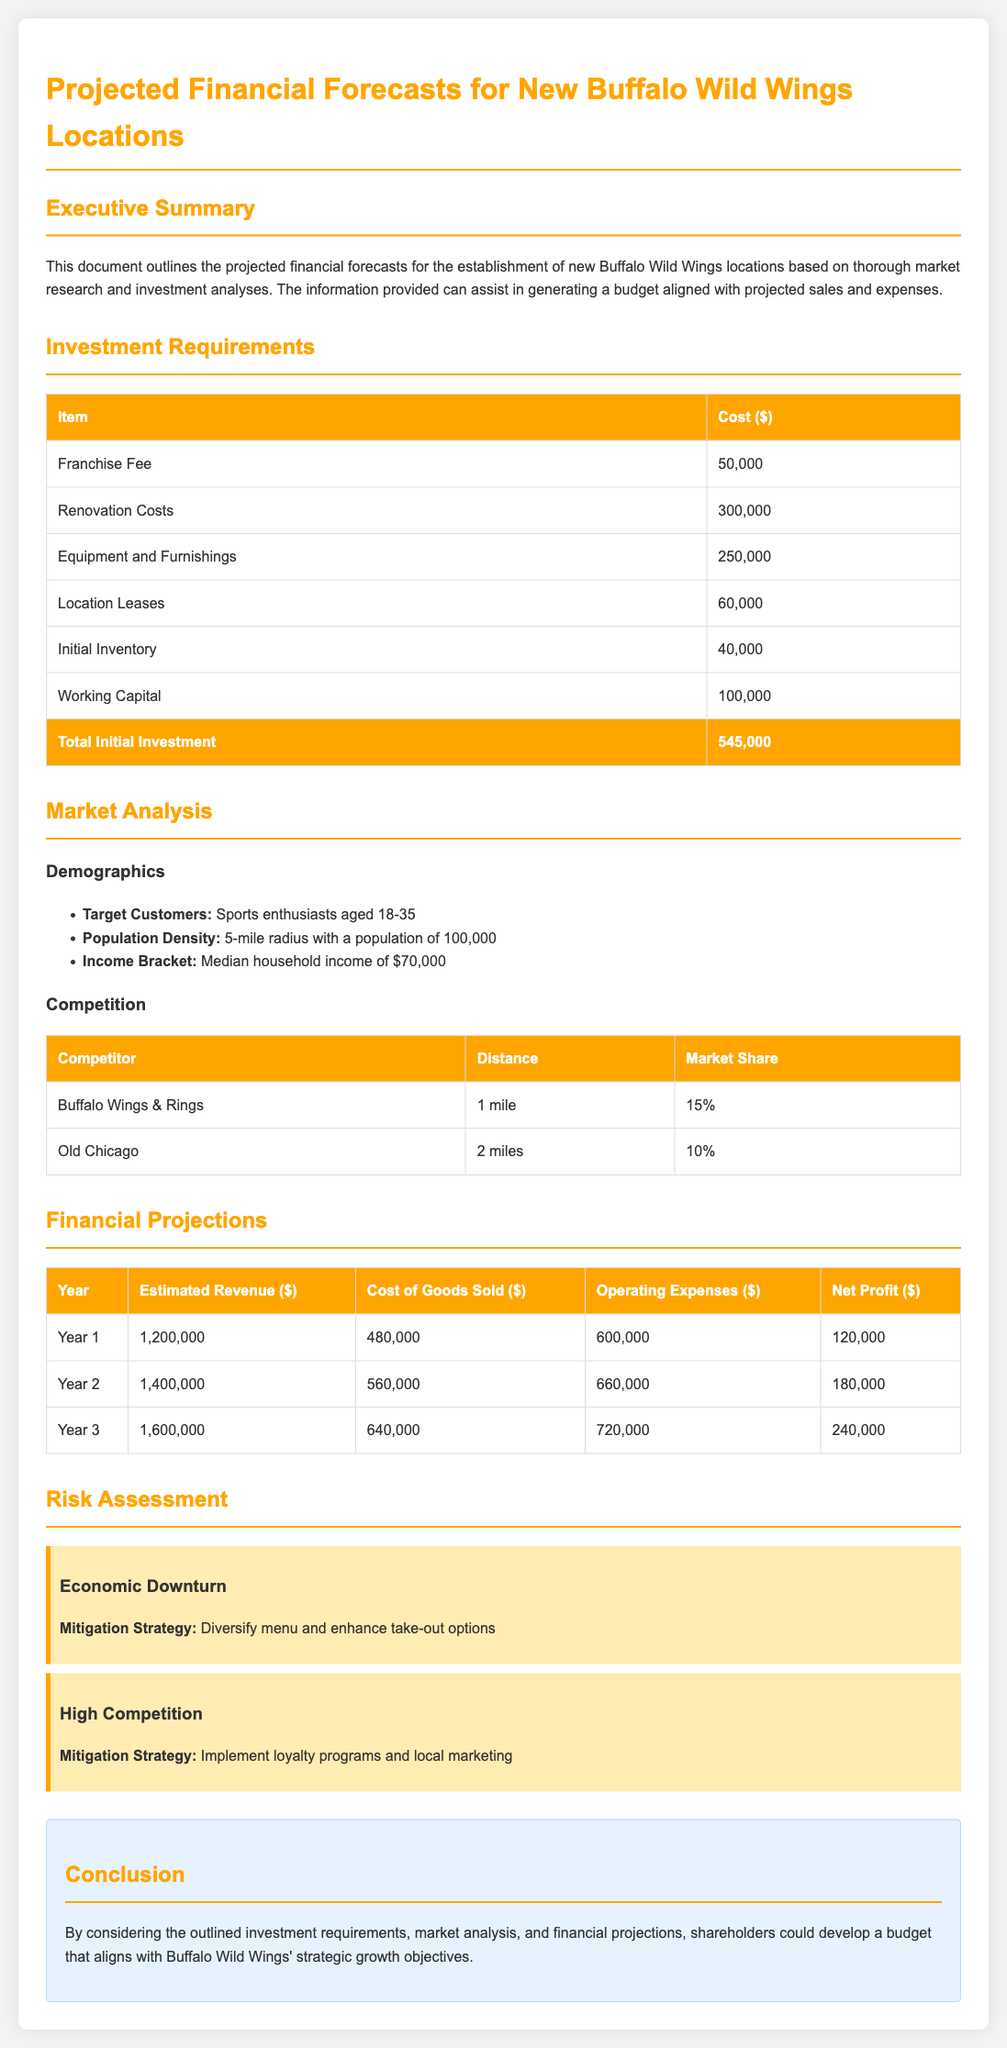What is the franchise fee? The franchise fee is listed in the Investment Requirements table.
Answer: 50,000 What is the total initial investment? The total initial investment amount is the last row of the Investment Requirements table.
Answer: 545,000 Who are the target customers? The target customers are specified in the Market Analysis section under Demographics.
Answer: Sports enthusiasts aged 18-35 What is the estimated revenue for Year 2? The estimated revenue for Year 2 is found in the Financial Projections table.
Answer: 1,400,000 What is the mitigation strategy for high competition? The mitigation strategy for high competition is outlined in the Risk Assessment section.
Answer: Implement loyalty programs and local marketing What is the median household income in the targeted area? The median household income is stated in the Market Analysis section under Demographics.
Answer: 70,000 What are the operating expenses for Year 3? The operating expenses for Year 3 can be found in the Financial Projections table.
Answer: 720,000 What are the renovation costs? Renovation costs are mentioned in the Investment Requirements table.
Answer: 300,000 What is the market share of Buffalo Wings & Rings? The market share for Buffalo Wings & Rings can be found in the Competition table.
Answer: 15% 